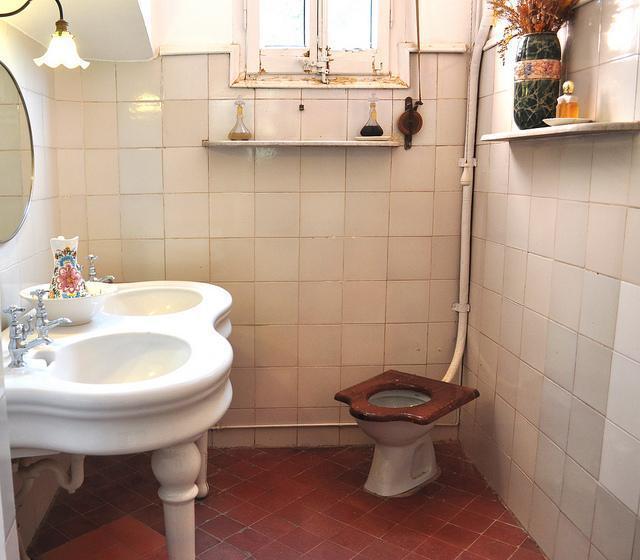How many sinks are there?
Give a very brief answer. 2. How many vases are in the photo?
Give a very brief answer. 1. How many giraffes are there?
Give a very brief answer. 0. 